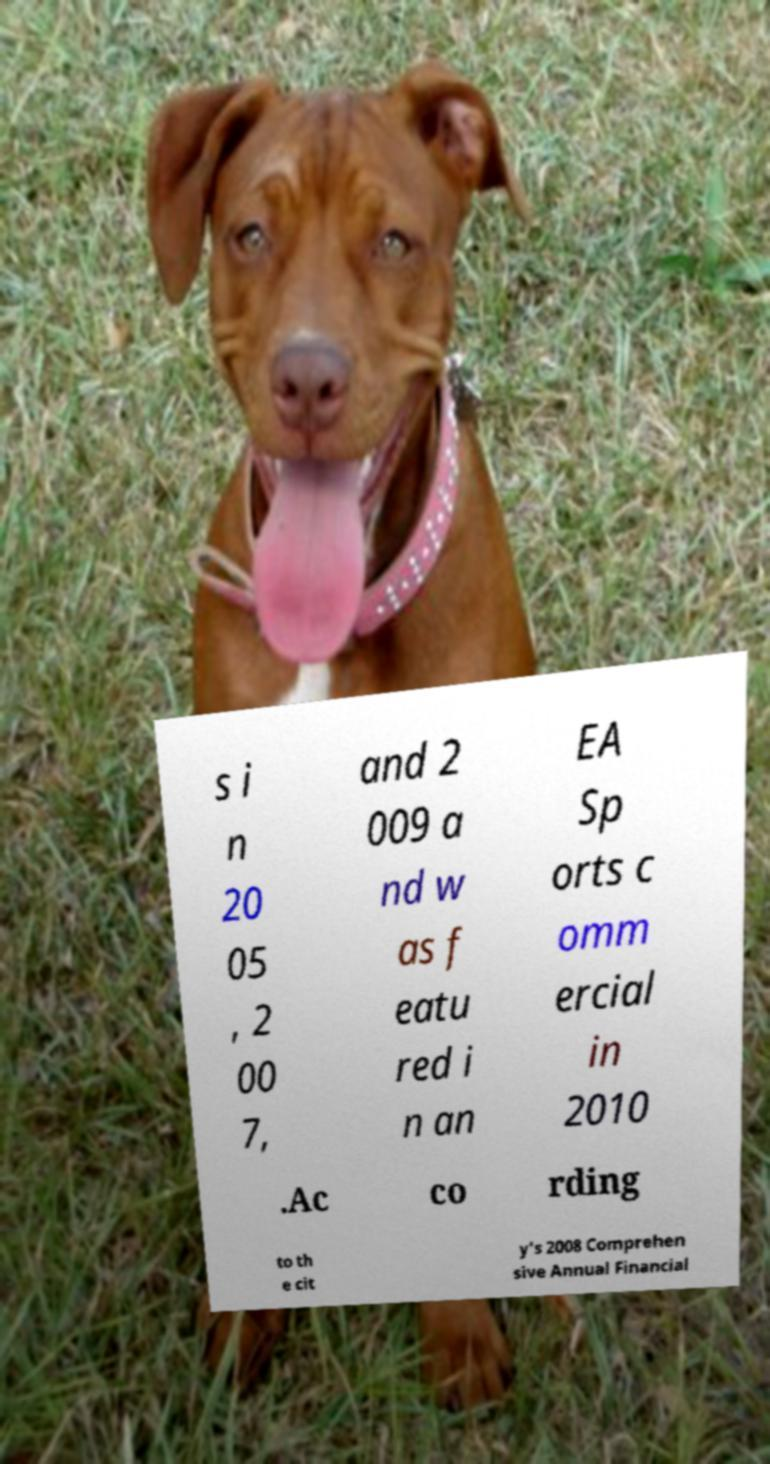Please identify and transcribe the text found in this image. s i n 20 05 , 2 00 7, and 2 009 a nd w as f eatu red i n an EA Sp orts c omm ercial in 2010 .Ac co rding to th e cit y's 2008 Comprehen sive Annual Financial 